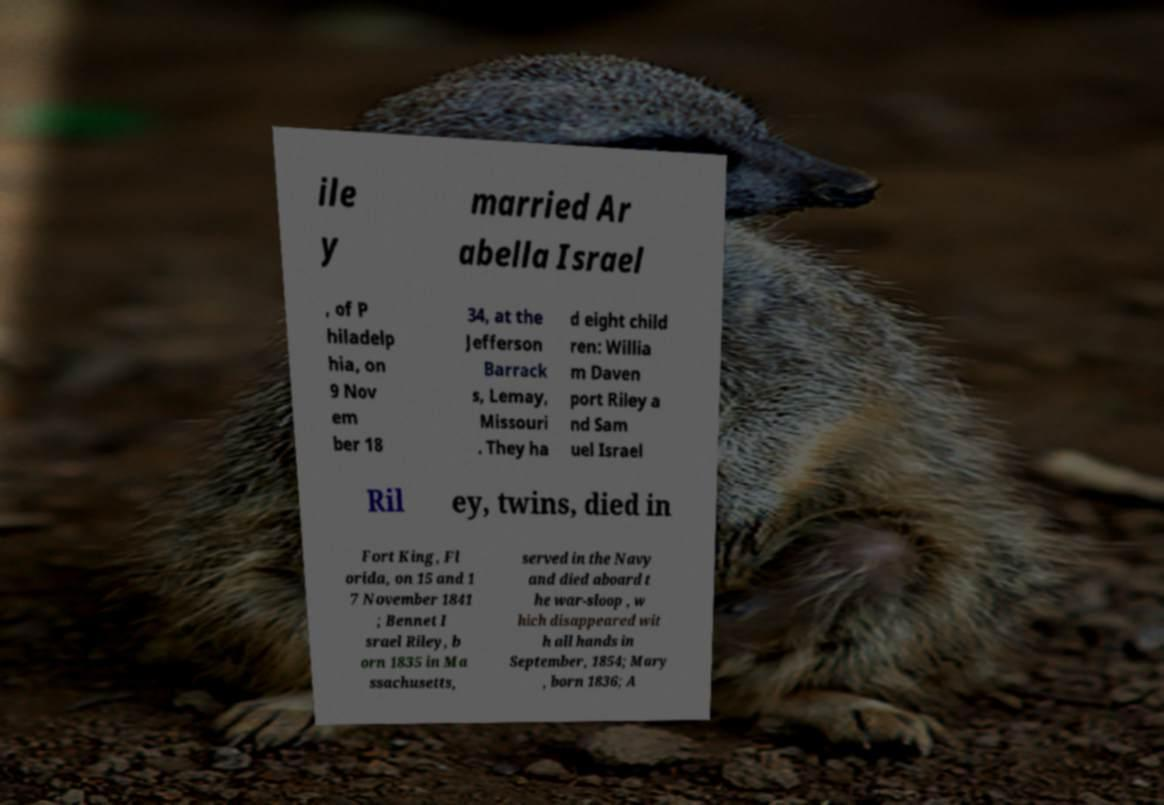There's text embedded in this image that I need extracted. Can you transcribe it verbatim? ile y married Ar abella Israel , of P hiladelp hia, on 9 Nov em ber 18 34, at the Jefferson Barrack s, Lemay, Missouri . They ha d eight child ren: Willia m Daven port Riley a nd Sam uel Israel Ril ey, twins, died in Fort King, Fl orida, on 15 and 1 7 November 1841 ; Bennet I srael Riley, b orn 1835 in Ma ssachusetts, served in the Navy and died aboard t he war-sloop , w hich disappeared wit h all hands in September, 1854; Mary , born 1836; A 